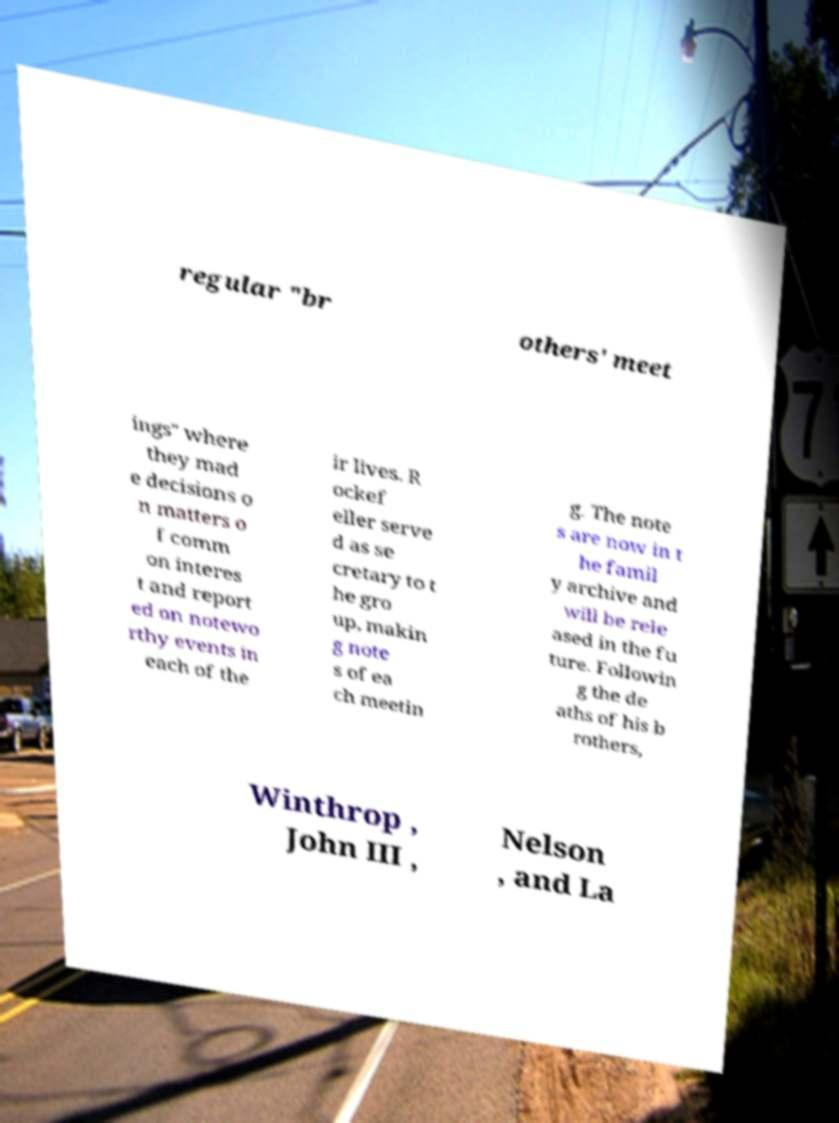Can you accurately transcribe the text from the provided image for me? regular "br others' meet ings" where they mad e decisions o n matters o f comm on interes t and report ed on notewo rthy events in each of the ir lives. R ockef eller serve d as se cretary to t he gro up, makin g note s of ea ch meetin g. The note s are now in t he famil y archive and will be rele ased in the fu ture. Followin g the de aths of his b rothers, Winthrop , John III , Nelson , and La 